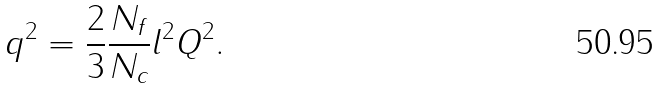<formula> <loc_0><loc_0><loc_500><loc_500>q ^ { 2 } = \frac { 2 } { 3 } \frac { N _ { f } } { N _ { c } } l ^ { 2 } Q ^ { 2 } .</formula> 